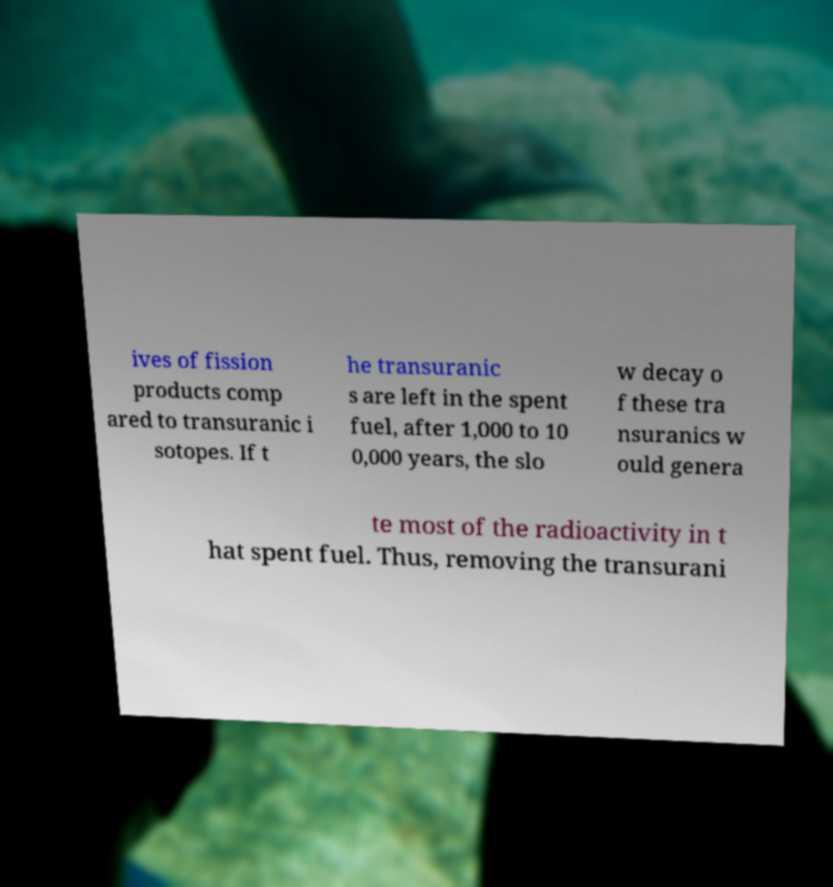I need the written content from this picture converted into text. Can you do that? ives of fission products comp ared to transuranic i sotopes. If t he transuranic s are left in the spent fuel, after 1,000 to 10 0,000 years, the slo w decay o f these tra nsuranics w ould genera te most of the radioactivity in t hat spent fuel. Thus, removing the transurani 